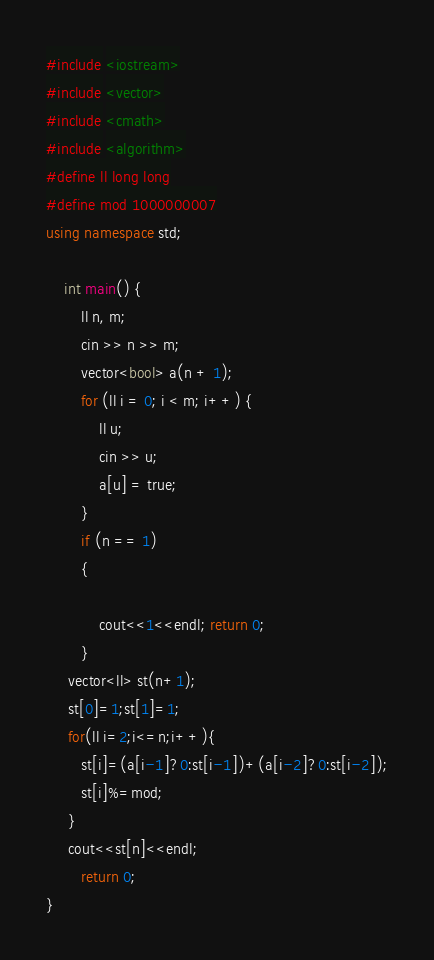<code> <loc_0><loc_0><loc_500><loc_500><_C++_>#include <iostream>
#include <vector>
#include <cmath>
#include <algorithm>
#define ll long long
#define mod 1000000007
using namespace std;

    int main() {
        ll n, m;
        cin >> n >> m;
        vector<bool> a(n + 1);
        for (ll i = 0; i < m; i++) {
            ll u;
            cin >> u;
            a[u] = true;
        }
        if (n == 1)
        {

            cout<<1<<endl; return 0;
        }
     vector<ll> st(n+1);
     st[0]=1;st[1]=1;
     for(ll i=2;i<=n;i++){
        st[i]=(a[i-1]?0:st[i-1])+(a[i-2]?0:st[i-2]);
        st[i]%=mod;
     }
     cout<<st[n]<<endl;
        return 0;
}

</code> 